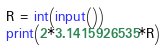Convert code to text. <code><loc_0><loc_0><loc_500><loc_500><_Python_>R = int(input())
print(2*3.1415926535*R)</code> 